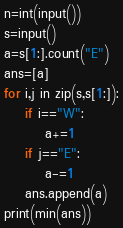<code> <loc_0><loc_0><loc_500><loc_500><_Python_>n=int(input())
s=input()
a=s[1:].count("E")
ans=[a]
for i,j in zip(s,s[1:]):
    if i=="W":
        a+=1
    if j=="E":
        a-=1
    ans.append(a)
print(min(ans))  </code> 